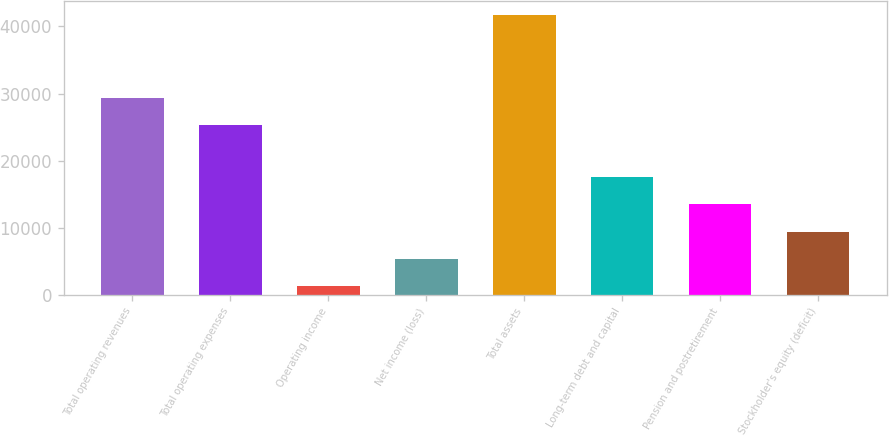Convert chart to OTSL. <chart><loc_0><loc_0><loc_500><loc_500><bar_chart><fcel>Total operating revenues<fcel>Total operating expenses<fcel>Operating income<fcel>Net income (loss)<fcel>Total assets<fcel>Long-term debt and capital<fcel>Pension and postretirement<fcel>Stockholder's equity (deficit)<nl><fcel>29374.9<fcel>25341<fcel>1360<fcel>5393.9<fcel>41699<fcel>17495.6<fcel>13461.7<fcel>9427.8<nl></chart> 